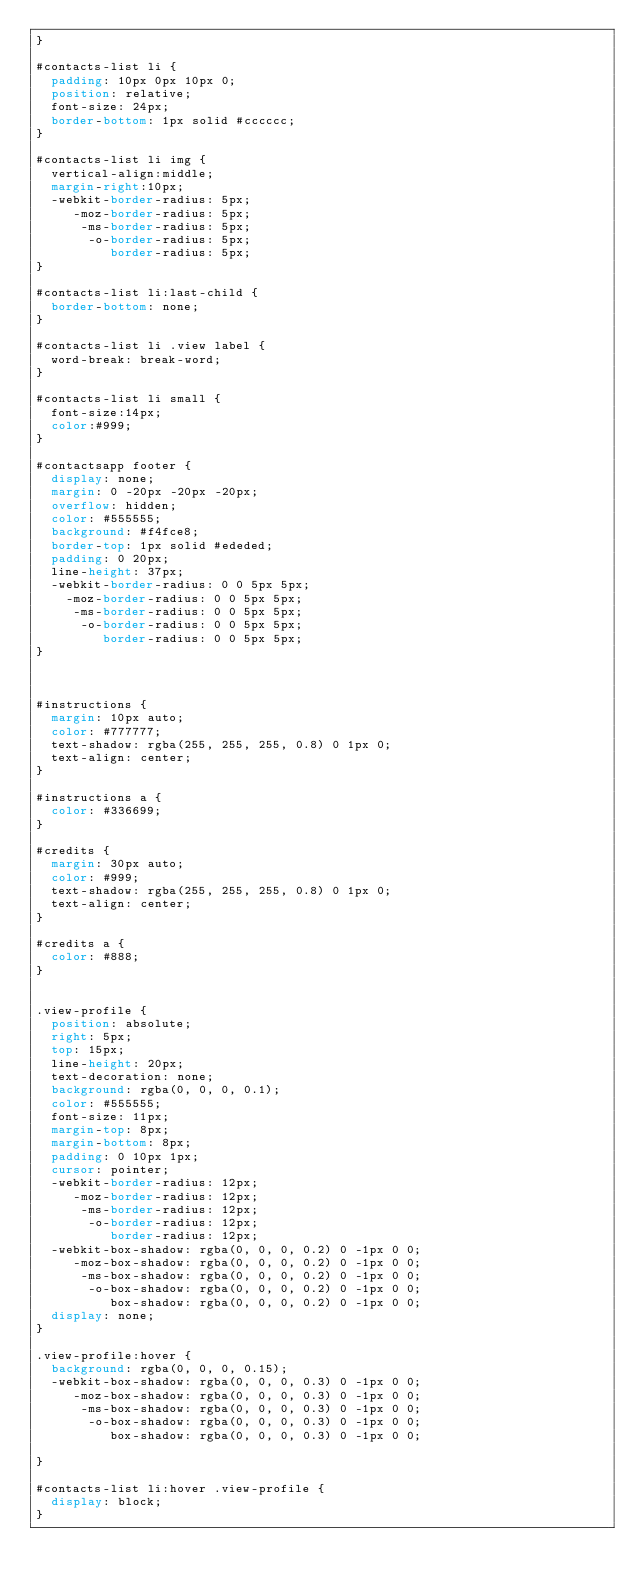Convert code to text. <code><loc_0><loc_0><loc_500><loc_500><_CSS_>}

#contacts-list li {
	padding: 10px 0px 10px 0;
	position: relative;
	font-size: 24px;
	border-bottom: 1px solid #cccccc;
}

#contacts-list li img {
  vertical-align:middle;
  margin-right:10px;
	-webkit-border-radius: 5px;
	   -moz-border-radius: 5px;
	    -ms-border-radius: 5px;
	     -o-border-radius: 5px;
  	      border-radius: 5px;
}

#contacts-list li:last-child {
	border-bottom: none;
}

#contacts-list li .view label {
	word-break: break-word;
}

#contacts-list li small {
  font-size:14px;
  color:#999;
}

#contactsapp footer {
	display: none;
	margin: 0 -20px -20px -20px;
	overflow: hidden;
	color: #555555;
	background: #f4fce8;
	border-top: 1px solid #ededed;
	padding: 0 20px;
	line-height: 37px;
	-webkit-border-radius: 0 0 5px 5px;
	  -moz-border-radius: 0 0 5px 5px;
	   -ms-border-radius: 0 0 5px 5px;
	    -o-border-radius: 0 0 5px 5px;
	       border-radius: 0 0 5px 5px;
}



#instructions {
	margin: 10px auto;
	color: #777777;
	text-shadow: rgba(255, 255, 255, 0.8) 0 1px 0;
	text-align: center;
}

#instructions a {
	color: #336699;
}

#credits {
	margin: 30px auto;
	color: #999;
	text-shadow: rgba(255, 255, 255, 0.8) 0 1px 0;
	text-align: center;
}

#credits a {
	color: #888;
}


.view-profile {
	position: absolute;
	right: 5px;
	top: 15px;
	line-height: 20px;
	text-decoration: none;
	background: rgba(0, 0, 0, 0.1);
	color: #555555;
	font-size: 11px;
	margin-top: 8px;
	margin-bottom: 8px;
	padding: 0 10px 1px;
	cursor: pointer;	
	-webkit-border-radius: 12px;
	   -moz-border-radius: 12px;
	    -ms-border-radius: 12px;
	     -o-border-radius: 12px;
	        border-radius: 12px;
	-webkit-box-shadow: rgba(0, 0, 0, 0.2) 0 -1px 0 0;
	   -moz-box-shadow: rgba(0, 0, 0, 0.2) 0 -1px 0 0;
	    -ms-box-shadow: rgba(0, 0, 0, 0.2) 0 -1px 0 0;
	     -o-box-shadow: rgba(0, 0, 0, 0.2) 0 -1px 0 0;
	        box-shadow: rgba(0, 0, 0, 0.2) 0 -1px 0 0;
	display: none;
}

.view-profile:hover {
	background: rgba(0, 0, 0, 0.15);
	-webkit-box-shadow: rgba(0, 0, 0, 0.3) 0 -1px 0 0;
	   -moz-box-shadow: rgba(0, 0, 0, 0.3) 0 -1px 0 0;
	    -ms-box-shadow: rgba(0, 0, 0, 0.3) 0 -1px 0 0;
	     -o-box-shadow: rgba(0, 0, 0, 0.3) 0 -1px 0 0;
	        box-shadow: rgba(0, 0, 0, 0.3) 0 -1px 0 0;

}

#contacts-list li:hover .view-profile {
  display: block;
}</code> 